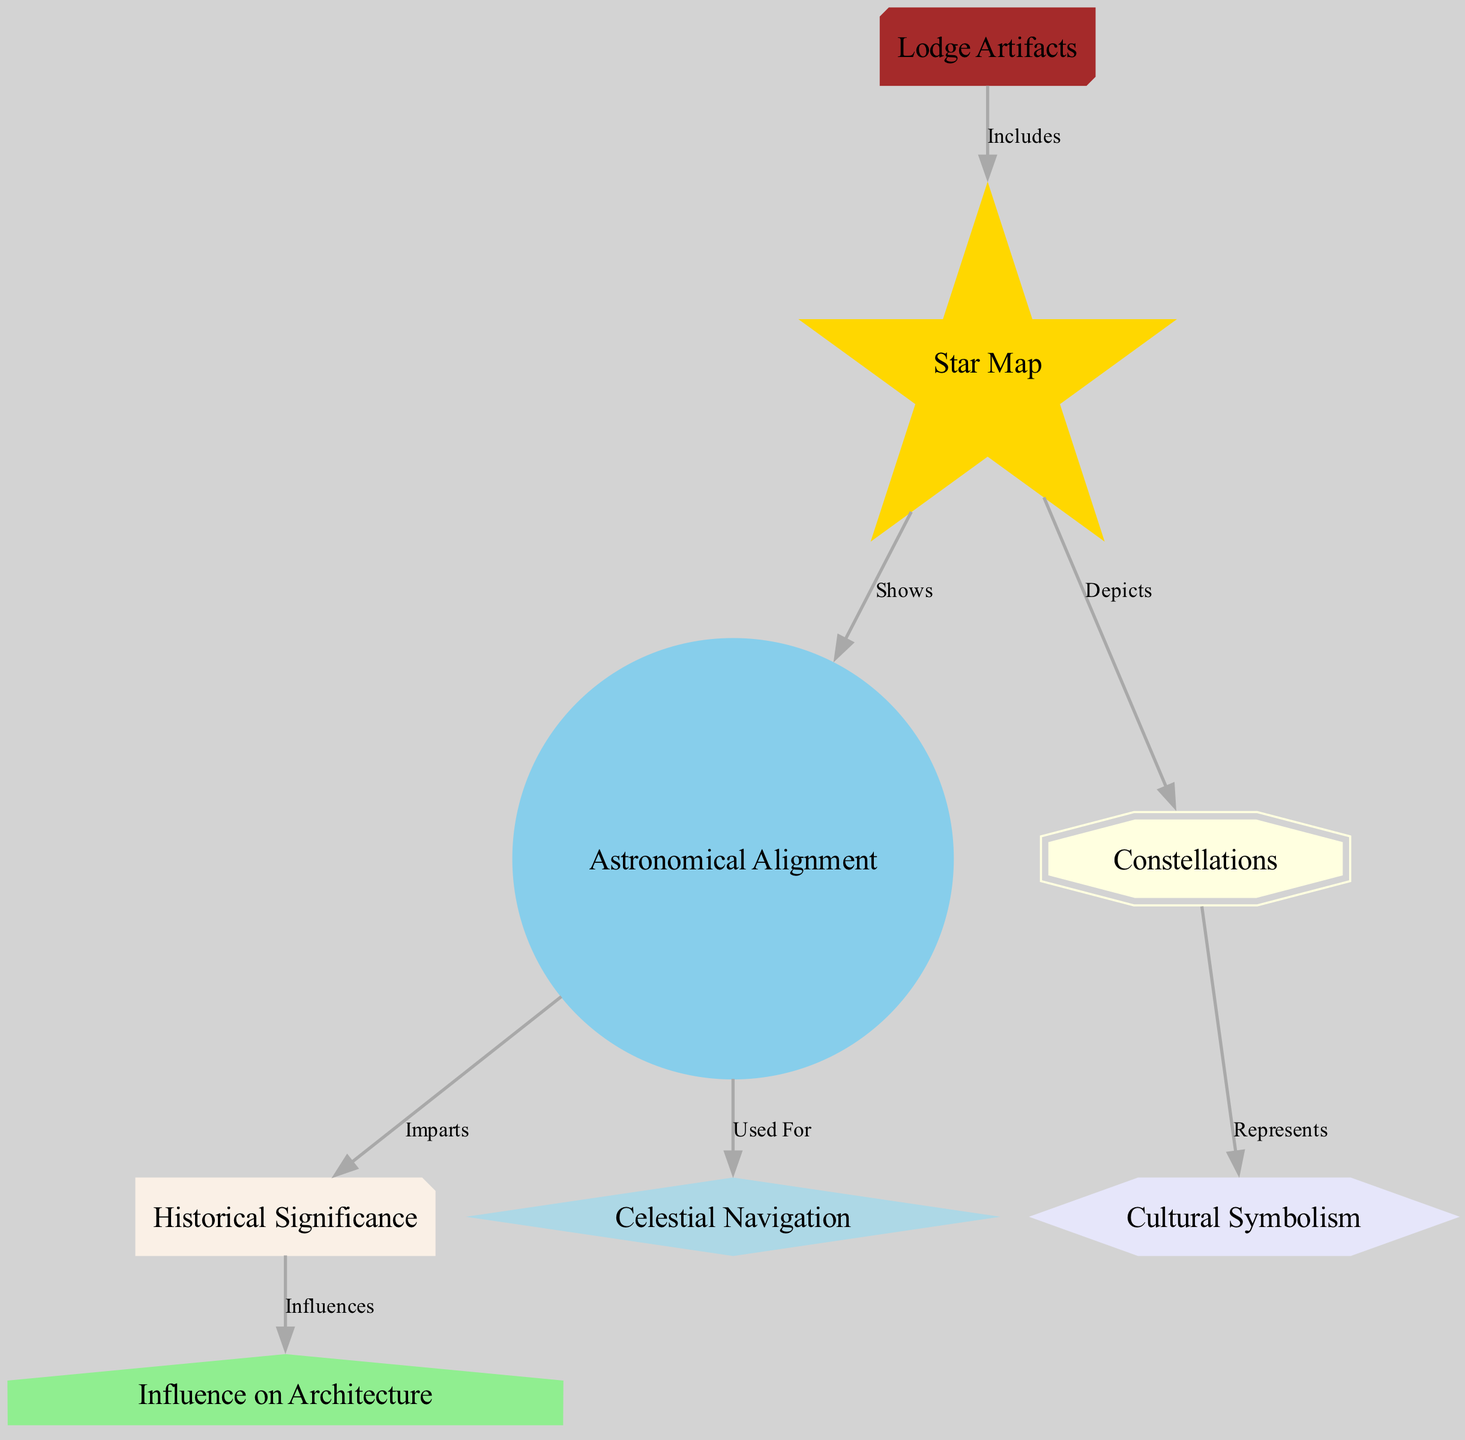What is depicted in the Star Map? The diagram indicates that the Star Map depicts constellations, which are shown as a direct relationship in the flow from the Star Map to the Constellations node.
Answer: Constellations How many edges are in the diagram? Counting each connection linking the nodes, I find there are a total of seven edges depicted in the diagram.
Answer: 7 What influence does Historical Significance have? The Historical Significance node influences the Architecture Influence node, forming a direct connection that indicates one impacts the other.
Answer: Architecture Influence What is used for celestial navigation? Referring to the directed edge from the Astronomical Alignment node, it indicates that the Astronomical Alignment is utilized for celestial navigation.
Answer: Astronomical Alignment Which node represents cultural symbolism? By checking the edges emerging from the Constellations node, it is shown that the Cultural Symbolism node represents cultural elements derived from the constellations.
Answer: Cultural Symbolism What relationship exists between Astronomical Alignment and Historical Significance? The relationship indicated in the diagram between the Astronomical Alignment and Historical Significance is that Astronomical Alignment imparts Historical Significance.
Answer: Imparts Which components are included in Lodge Artifacts? The diagram specifies that Lodge Artifacts include the Star Map as a primary element, establishing a direct relationship.
Answer: Star Map What does the Star Map show? The diagram clearly illustrates that the Star Map shows the Astronomical Alignment, indicating what information is conveyed by the Star Map.
Answer: Astronomical Alignment 